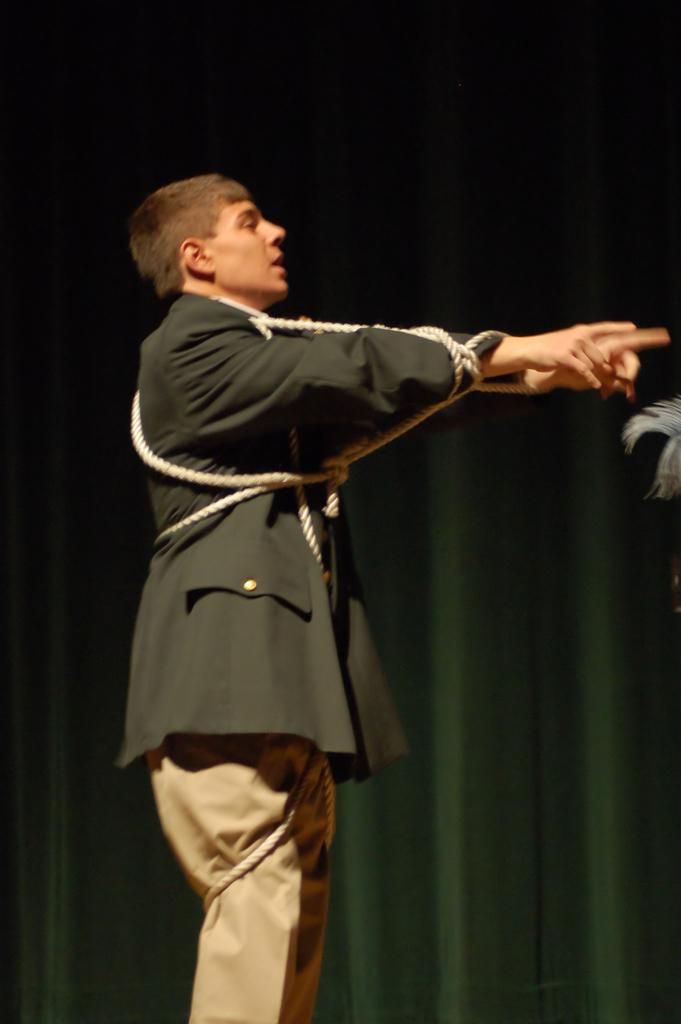What is happening in the foreground of the image? There is a person standing on the stage in the foreground. What can be seen in the background of the image? There is a curtain in the background. What type of setting is suggested by the presence of a stage? The image is likely taken on a stage, which might indicate a performance or event. What type of straw is being used by the bear in the image? There is no bear or straw present in the image. 